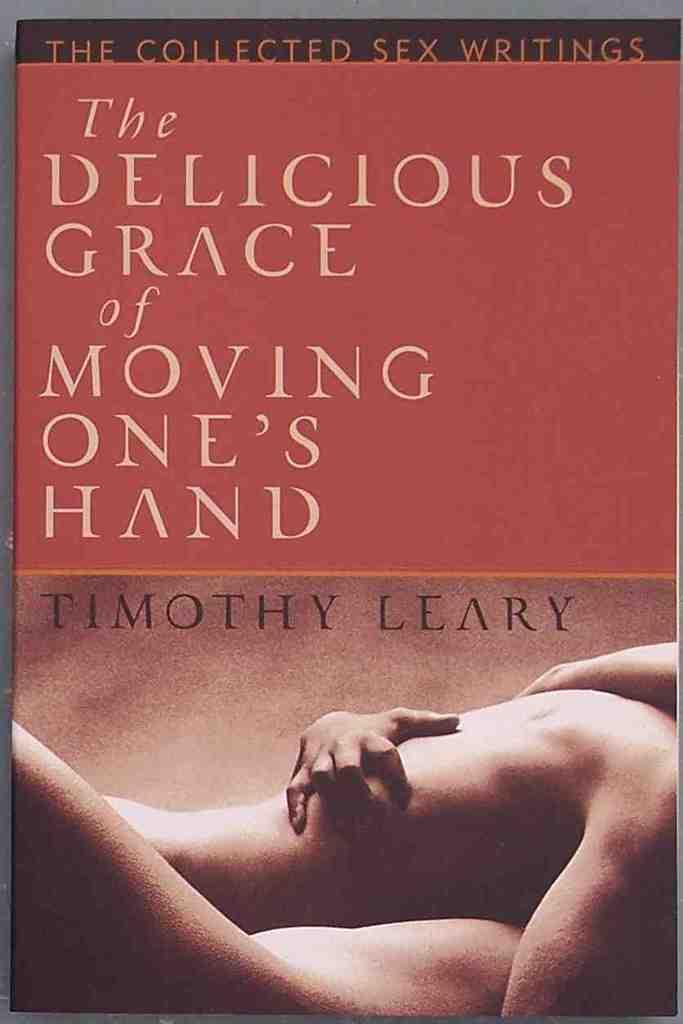Who is the author?
Your answer should be very brief. Timothy leary. What is the title of the book?
Your answer should be very brief. The delicious grace of moving one's hand. 